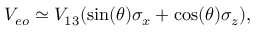<formula> <loc_0><loc_0><loc_500><loc_500>V _ { e o } \simeq V _ { 1 3 } ( \sin ( \theta ) \sigma _ { x } + \cos ( \theta ) \sigma _ { z } ) ,</formula> 